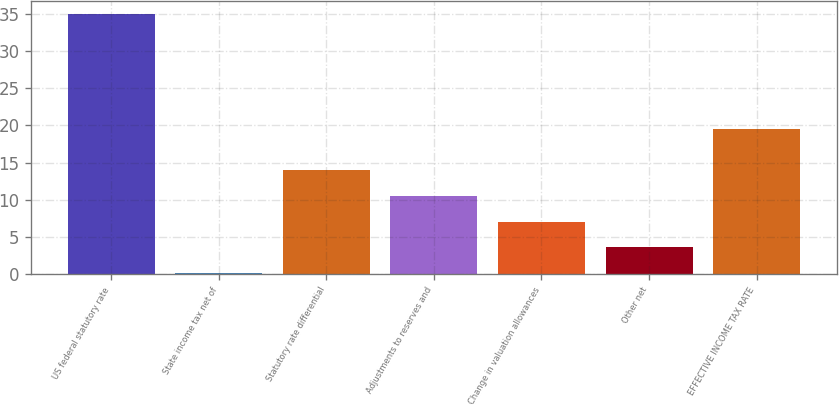<chart> <loc_0><loc_0><loc_500><loc_500><bar_chart><fcel>US federal statutory rate<fcel>State income tax net of<fcel>Statutory rate differential<fcel>Adjustments to reserves and<fcel>Change in valuation allowances<fcel>Other net<fcel>EFFECTIVE INCOME TAX RATE<nl><fcel>35<fcel>0.1<fcel>14.06<fcel>10.57<fcel>7.08<fcel>3.59<fcel>19.5<nl></chart> 